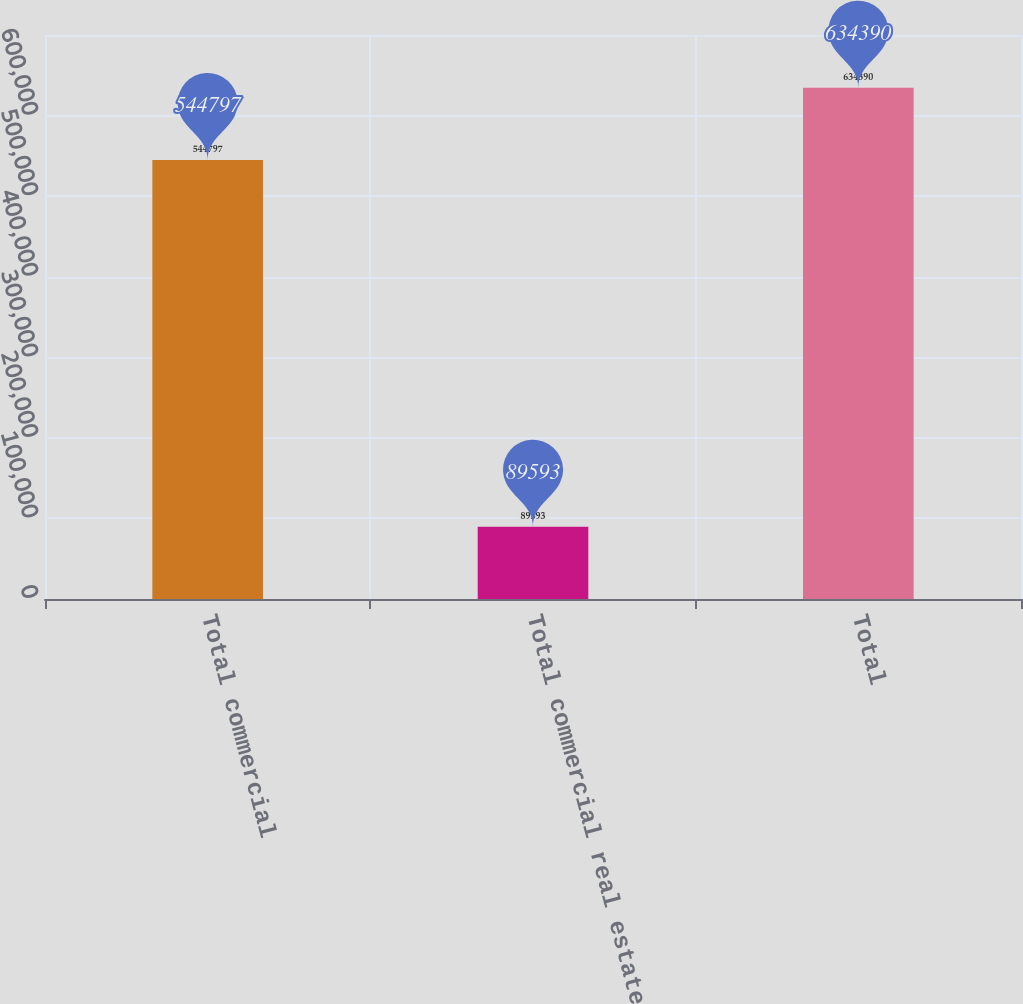Convert chart to OTSL. <chart><loc_0><loc_0><loc_500><loc_500><bar_chart><fcel>Total commercial<fcel>Total commercial real estate<fcel>Total<nl><fcel>544797<fcel>89593<fcel>634390<nl></chart> 